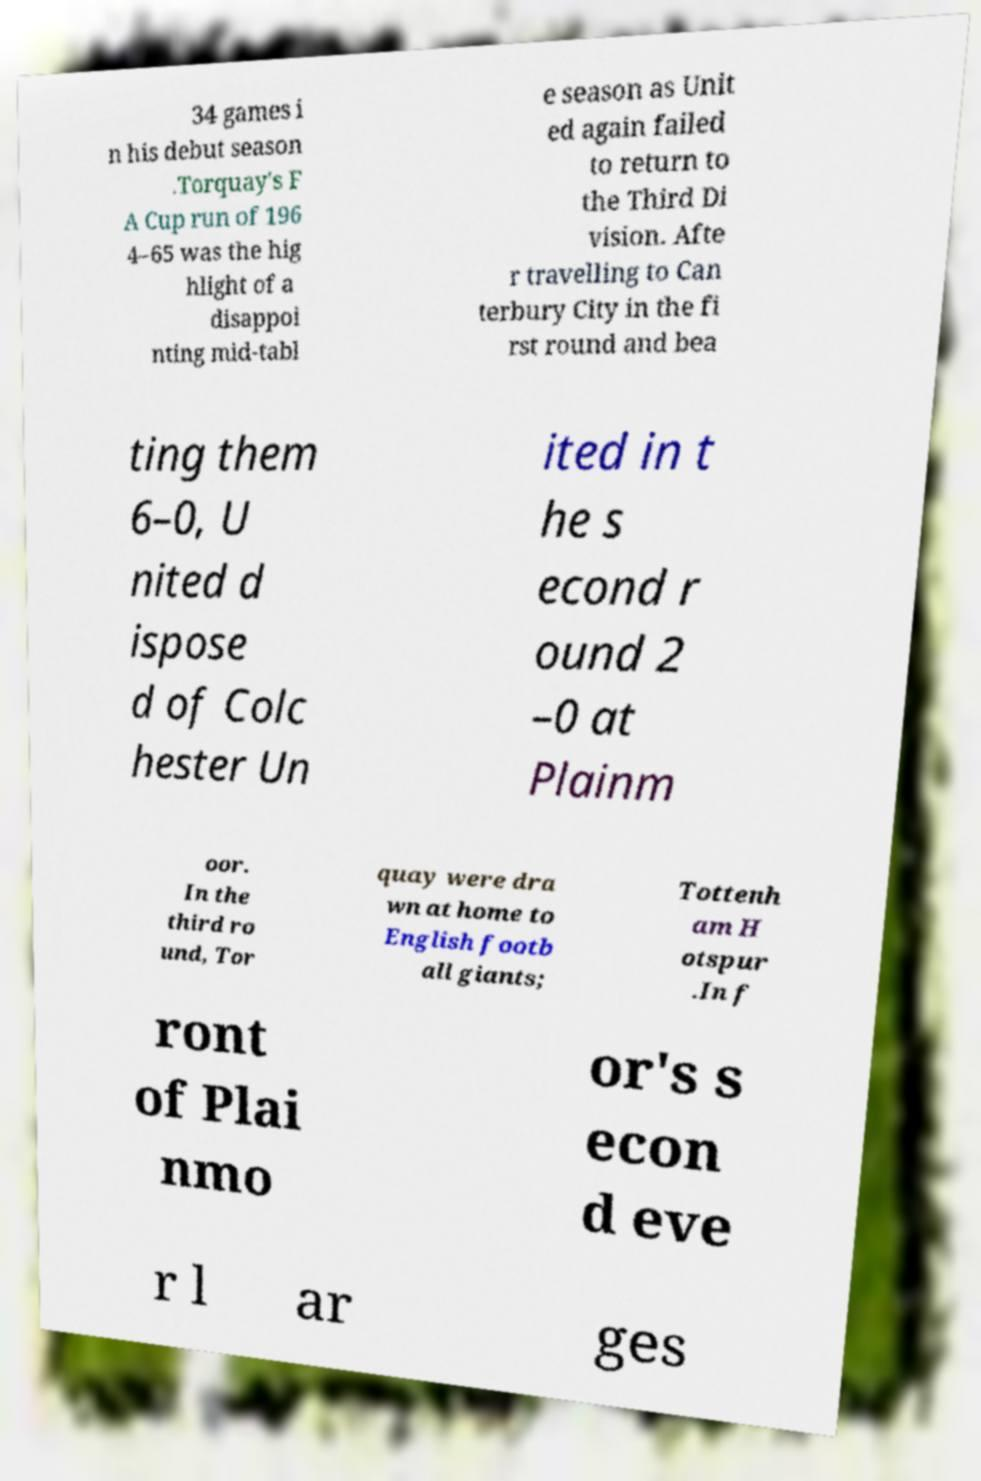There's text embedded in this image that I need extracted. Can you transcribe it verbatim? 34 games i n his debut season .Torquay's F A Cup run of 196 4–65 was the hig hlight of a disappoi nting mid-tabl e season as Unit ed again failed to return to the Third Di vision. Afte r travelling to Can terbury City in the fi rst round and bea ting them 6–0, U nited d ispose d of Colc hester Un ited in t he s econd r ound 2 –0 at Plainm oor. In the third ro und, Tor quay were dra wn at home to English footb all giants; Tottenh am H otspur .In f ront of Plai nmo or's s econ d eve r l ar ges 